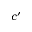<formula> <loc_0><loc_0><loc_500><loc_500>c ^ { \prime }</formula> 